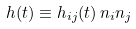<formula> <loc_0><loc_0><loc_500><loc_500>h ( t ) \equiv h _ { i j } ( t ) \, n _ { i } n _ { j }</formula> 